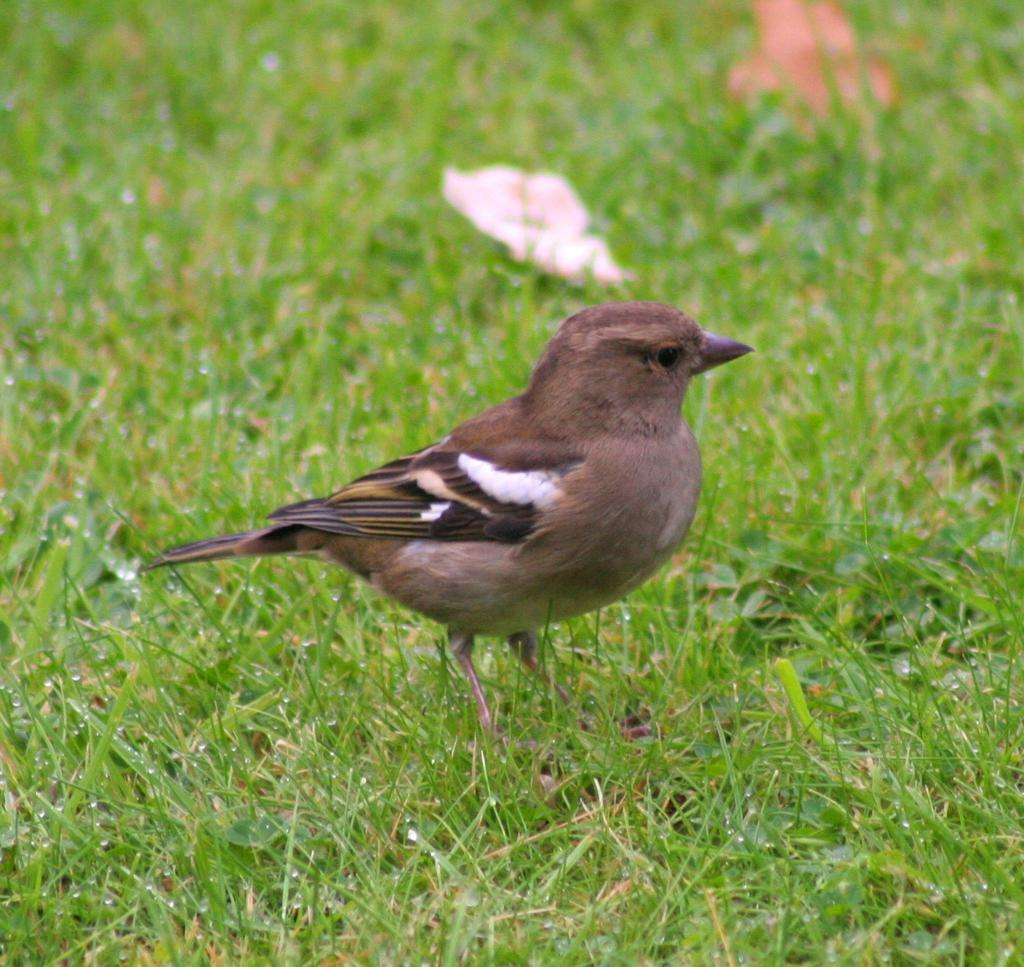What type of animal can be seen in the image? There is a bird in the image. What is the color of the grass in the image? There is green grass in the image. What can be seen at the top of the image? Leaves are visible at the top of the image. What is the color of the white object in the image? There is a white object in the image. What type of mine is visible in the image? There is no mine present in the image; it features a bird, green grass, leaves, and a white object. 